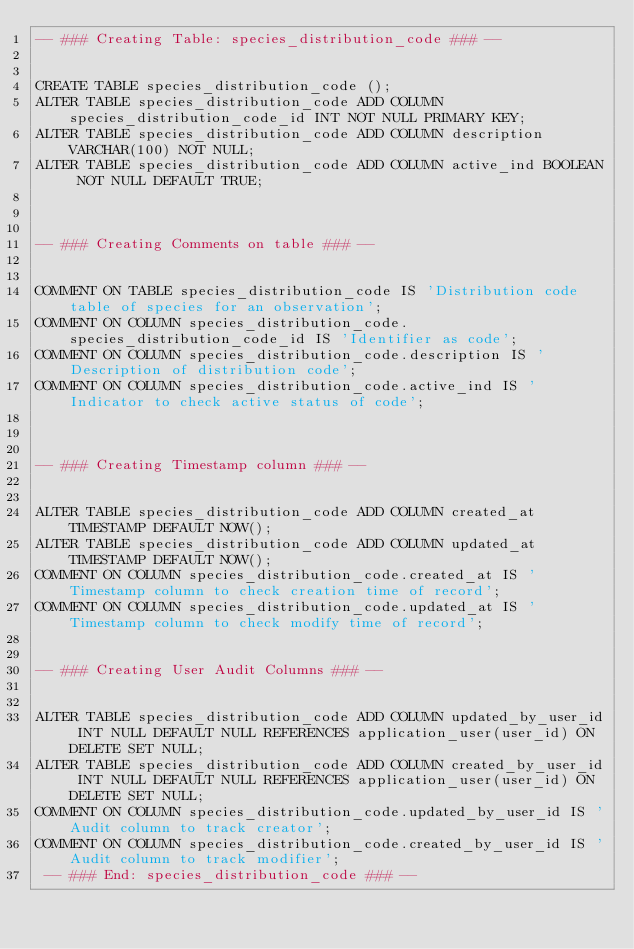<code> <loc_0><loc_0><loc_500><loc_500><_SQL_>-- ### Creating Table: species_distribution_code ### --

        
CREATE TABLE species_distribution_code ();
ALTER TABLE species_distribution_code ADD COLUMN species_distribution_code_id INT NOT NULL PRIMARY KEY;
ALTER TABLE species_distribution_code ADD COLUMN description VARCHAR(100) NOT NULL;
ALTER TABLE species_distribution_code ADD COLUMN active_ind BOOLEAN NOT NULL DEFAULT TRUE;


        
-- ### Creating Comments on table ### --

        
COMMENT ON TABLE species_distribution_code IS 'Distribution code table of species for an observation';
COMMENT ON COLUMN species_distribution_code.species_distribution_code_id IS 'Identifier as code';
COMMENT ON COLUMN species_distribution_code.description IS 'Description of distribution code';
COMMENT ON COLUMN species_distribution_code.active_ind IS 'Indicator to check active status of code';


        
-- ### Creating Timestamp column ### --

        
ALTER TABLE species_distribution_code ADD COLUMN created_at TIMESTAMP DEFAULT NOW();
ALTER TABLE species_distribution_code ADD COLUMN updated_at TIMESTAMP DEFAULT NOW();
COMMENT ON COLUMN species_distribution_code.created_at IS 'Timestamp column to check creation time of record';
COMMENT ON COLUMN species_distribution_code.updated_at IS 'Timestamp column to check modify time of record';

        
-- ### Creating User Audit Columns ### --

        
ALTER TABLE species_distribution_code ADD COLUMN updated_by_user_id INT NULL DEFAULT NULL REFERENCES application_user(user_id) ON DELETE SET NULL;
ALTER TABLE species_distribution_code ADD COLUMN created_by_user_id INT NULL DEFAULT NULL REFERENCES application_user(user_id) ON DELETE SET NULL;
COMMENT ON COLUMN species_distribution_code.updated_by_user_id IS 'Audit column to track creator';
COMMENT ON COLUMN species_distribution_code.created_by_user_id IS 'Audit column to track modifier';
 -- ### End: species_distribution_code ### --
</code> 